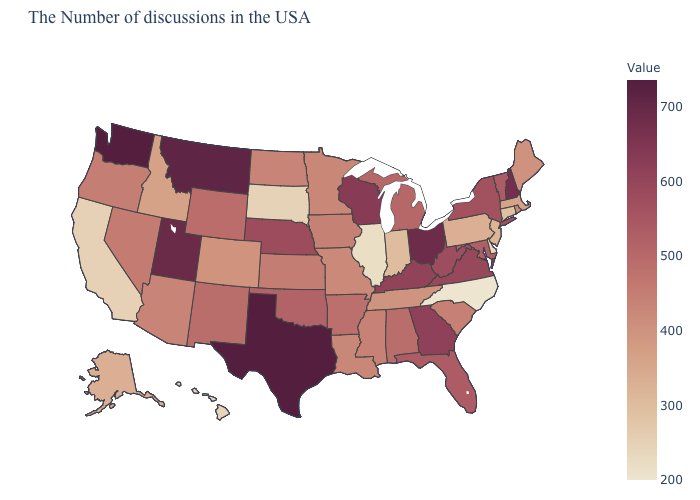Among the states that border Illinois , does Indiana have the lowest value?
Quick response, please. Yes. Among the states that border New York , which have the lowest value?
Write a very short answer. Connecticut. Does Texas have the highest value in the USA?
Concise answer only. Yes. Does Washington have the highest value in the USA?
Concise answer only. Yes. Does Connecticut have the lowest value in the Northeast?
Keep it brief. Yes. Does Louisiana have the lowest value in the South?
Keep it brief. No. Is the legend a continuous bar?
Answer briefly. Yes. 